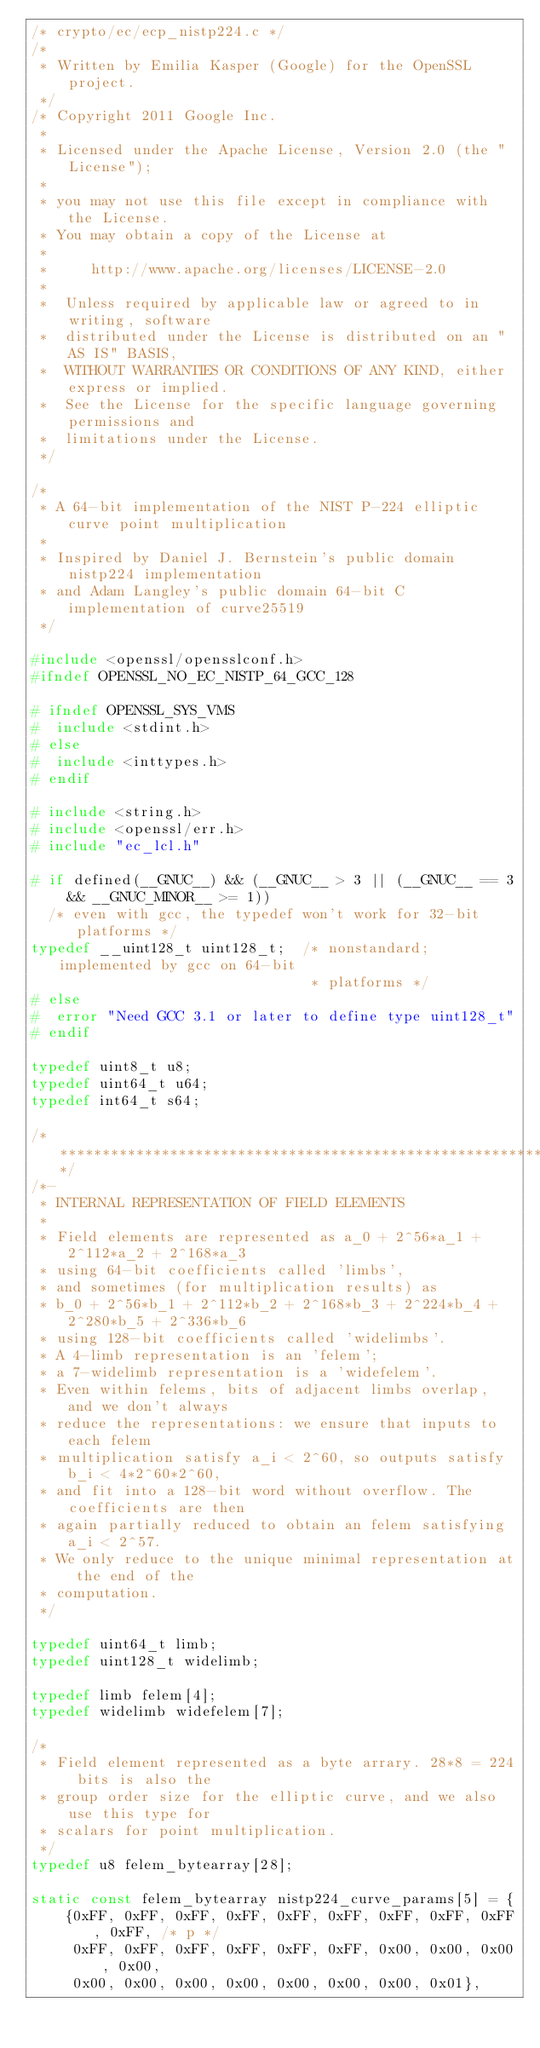<code> <loc_0><loc_0><loc_500><loc_500><_C_>/* crypto/ec/ecp_nistp224.c */
/*
 * Written by Emilia Kasper (Google) for the OpenSSL project.
 */
/* Copyright 2011 Google Inc.
 *
 * Licensed under the Apache License, Version 2.0 (the "License");
 *
 * you may not use this file except in compliance with the License.
 * You may obtain a copy of the License at
 *
 *     http://www.apache.org/licenses/LICENSE-2.0
 *
 *  Unless required by applicable law or agreed to in writing, software
 *  distributed under the License is distributed on an "AS IS" BASIS,
 *  WITHOUT WARRANTIES OR CONDITIONS OF ANY KIND, either express or implied.
 *  See the License for the specific language governing permissions and
 *  limitations under the License.
 */

/*
 * A 64-bit implementation of the NIST P-224 elliptic curve point multiplication
 *
 * Inspired by Daniel J. Bernstein's public domain nistp224 implementation
 * and Adam Langley's public domain 64-bit C implementation of curve25519
 */

#include <openssl/opensslconf.h>
#ifndef OPENSSL_NO_EC_NISTP_64_GCC_128

# ifndef OPENSSL_SYS_VMS
#  include <stdint.h>
# else
#  include <inttypes.h>
# endif

# include <string.h>
# include <openssl/err.h>
# include "ec_lcl.h"

# if defined(__GNUC__) && (__GNUC__ > 3 || (__GNUC__ == 3 && __GNUC_MINOR__ >= 1))
  /* even with gcc, the typedef won't work for 32-bit platforms */
typedef __uint128_t uint128_t;  /* nonstandard; implemented by gcc on 64-bit
                                 * platforms */
# else
#  error "Need GCC 3.1 or later to define type uint128_t"
# endif

typedef uint8_t u8;
typedef uint64_t u64;
typedef int64_t s64;

/******************************************************************************/
/*-
 * INTERNAL REPRESENTATION OF FIELD ELEMENTS
 *
 * Field elements are represented as a_0 + 2^56*a_1 + 2^112*a_2 + 2^168*a_3
 * using 64-bit coefficients called 'limbs',
 * and sometimes (for multiplication results) as
 * b_0 + 2^56*b_1 + 2^112*b_2 + 2^168*b_3 + 2^224*b_4 + 2^280*b_5 + 2^336*b_6
 * using 128-bit coefficients called 'widelimbs'.
 * A 4-limb representation is an 'felem';
 * a 7-widelimb representation is a 'widefelem'.
 * Even within felems, bits of adjacent limbs overlap, and we don't always
 * reduce the representations: we ensure that inputs to each felem
 * multiplication satisfy a_i < 2^60, so outputs satisfy b_i < 4*2^60*2^60,
 * and fit into a 128-bit word without overflow. The coefficients are then
 * again partially reduced to obtain an felem satisfying a_i < 2^57.
 * We only reduce to the unique minimal representation at the end of the
 * computation.
 */

typedef uint64_t limb;
typedef uint128_t widelimb;

typedef limb felem[4];
typedef widelimb widefelem[7];

/*
 * Field element represented as a byte arrary. 28*8 = 224 bits is also the
 * group order size for the elliptic curve, and we also use this type for
 * scalars for point multiplication.
 */
typedef u8 felem_bytearray[28];

static const felem_bytearray nistp224_curve_params[5] = {
    {0xFF, 0xFF, 0xFF, 0xFF, 0xFF, 0xFF, 0xFF, 0xFF, 0xFF, 0xFF, /* p */
     0xFF, 0xFF, 0xFF, 0xFF, 0xFF, 0xFF, 0x00, 0x00, 0x00, 0x00,
     0x00, 0x00, 0x00, 0x00, 0x00, 0x00, 0x00, 0x01},</code> 